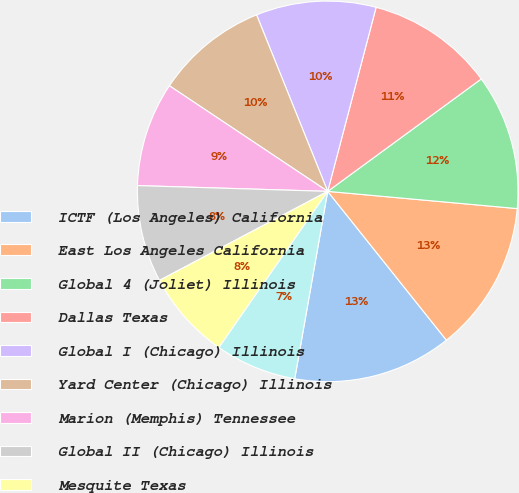Convert chart to OTSL. <chart><loc_0><loc_0><loc_500><loc_500><pie_chart><fcel>ICTF (Los Angeles) California<fcel>East Los Angeles California<fcel>Global 4 (Joliet) Illinois<fcel>Dallas Texas<fcel>Global I (Chicago) Illinois<fcel>Yard Center (Chicago) Illinois<fcel>Marion (Memphis) Tennessee<fcel>Global II (Chicago) Illinois<fcel>Mesquite Texas<fcel>LATC (Los Angeles) California<nl><fcel>13.49%<fcel>12.84%<fcel>11.5%<fcel>10.85%<fcel>10.19%<fcel>9.54%<fcel>8.88%<fcel>8.23%<fcel>7.57%<fcel>6.91%<nl></chart> 